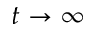<formula> <loc_0><loc_0><loc_500><loc_500>t \rightarrow \infty</formula> 